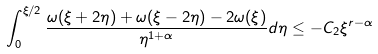<formula> <loc_0><loc_0><loc_500><loc_500>\int _ { 0 } ^ { \xi / 2 } \frac { \omega ( \xi + 2 \eta ) + \omega ( \xi - 2 \eta ) - 2 \omega ( \xi ) } { \eta ^ { 1 + \alpha } } d \eta \leq - C _ { 2 } \xi ^ { r - \alpha }</formula> 